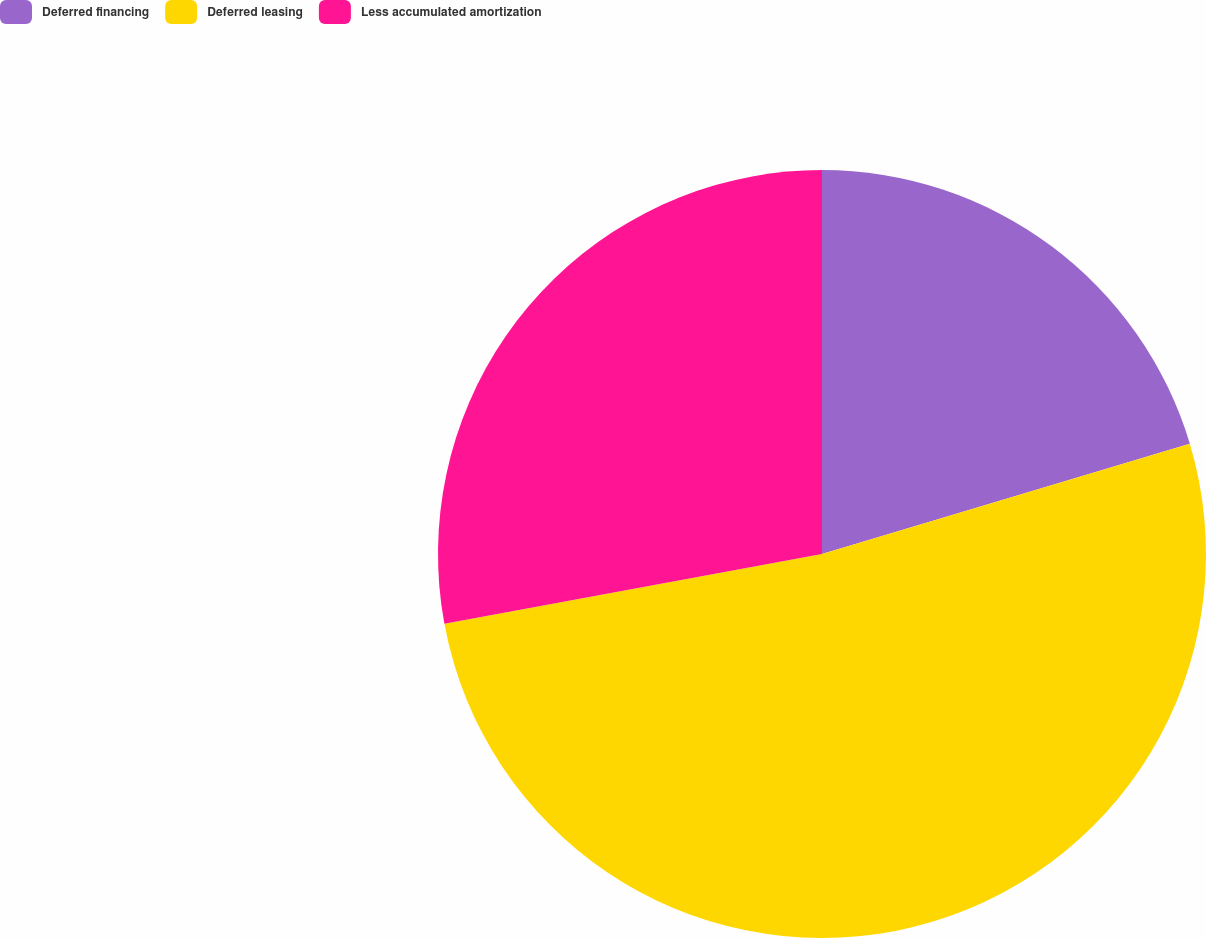Convert chart to OTSL. <chart><loc_0><loc_0><loc_500><loc_500><pie_chart><fcel>Deferred financing<fcel>Deferred leasing<fcel>Less accumulated amortization<nl><fcel>20.37%<fcel>51.73%<fcel>27.91%<nl></chart> 